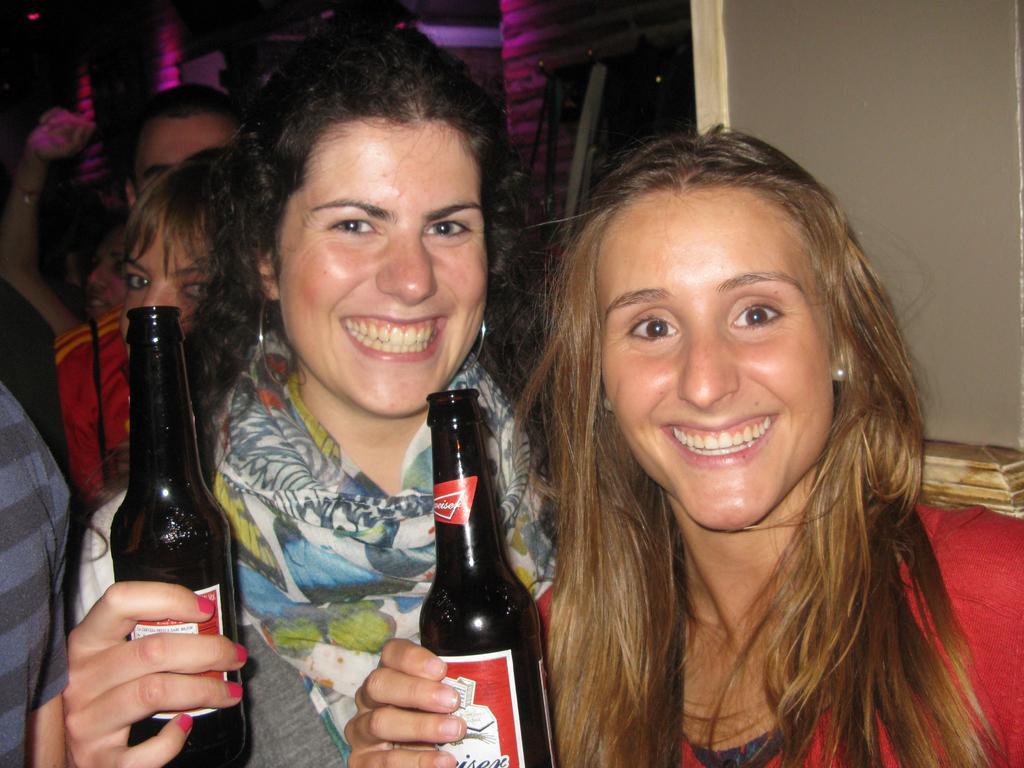In one or two sentences, can you explain what this image depicts? There are two ladies holding bottles and smiling. Middle lady is wearing a scarf. In the background there are many persons. 